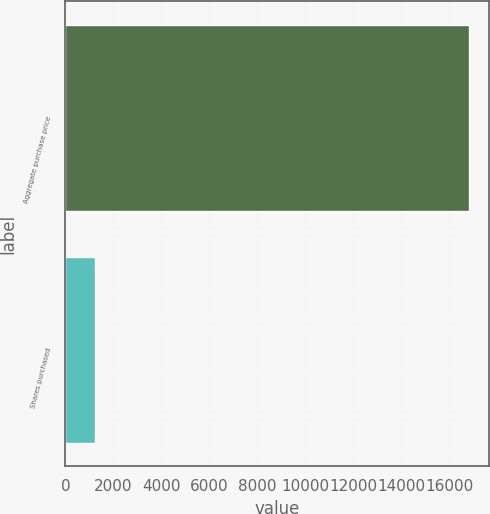Convert chart to OTSL. <chart><loc_0><loc_0><loc_500><loc_500><bar_chart><fcel>Aggregate purchase price<fcel>Shares purchased<nl><fcel>16816<fcel>1220<nl></chart> 